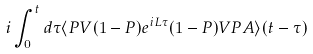Convert formula to latex. <formula><loc_0><loc_0><loc_500><loc_500>i \int _ { 0 } ^ { t } d \tau \langle P V ( 1 - P ) e ^ { i L \tau } ( 1 - P ) V P A \rangle ( t - \tau )</formula> 